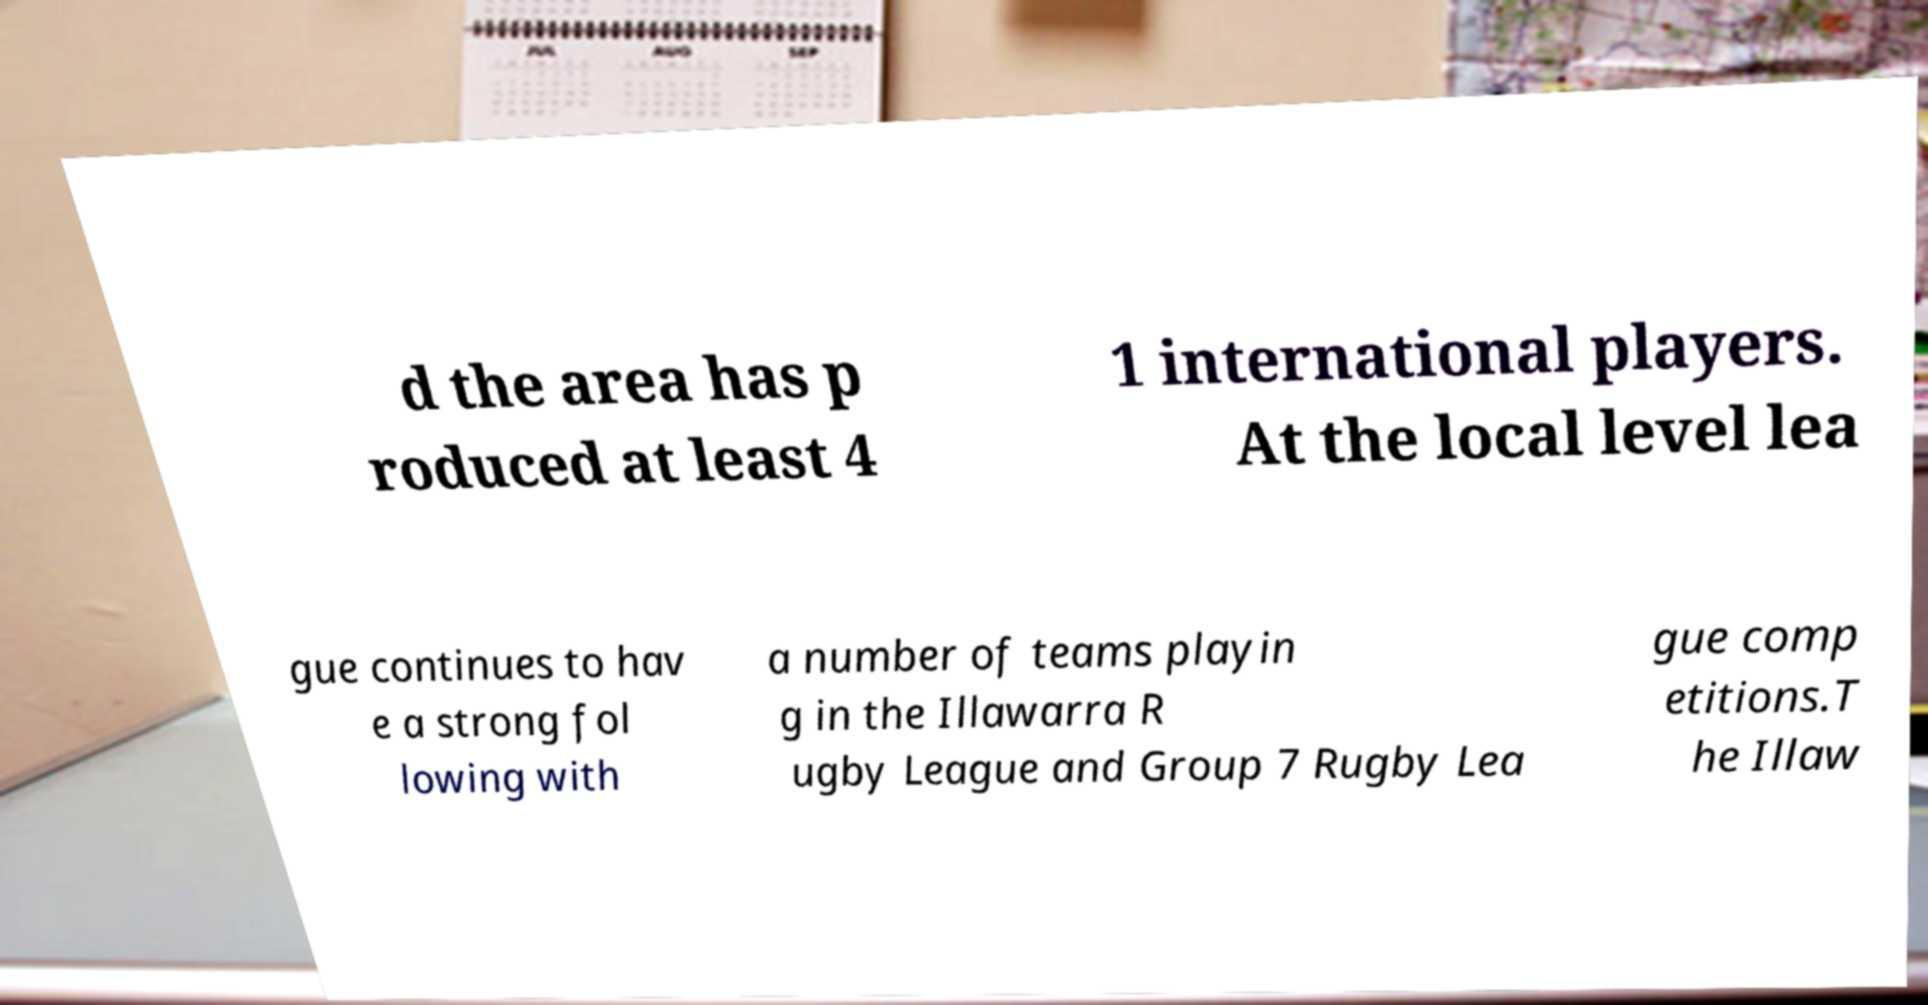There's text embedded in this image that I need extracted. Can you transcribe it verbatim? d the area has p roduced at least 4 1 international players. At the local level lea gue continues to hav e a strong fol lowing with a number of teams playin g in the Illawarra R ugby League and Group 7 Rugby Lea gue comp etitions.T he Illaw 